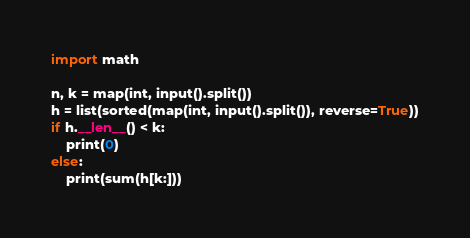Convert code to text. <code><loc_0><loc_0><loc_500><loc_500><_Python_>import math

n, k = map(int, input().split())
h = list(sorted(map(int, input().split()), reverse=True))
if h.__len__() < k:
    print(0)
else:
    print(sum(h[k:]))
</code> 